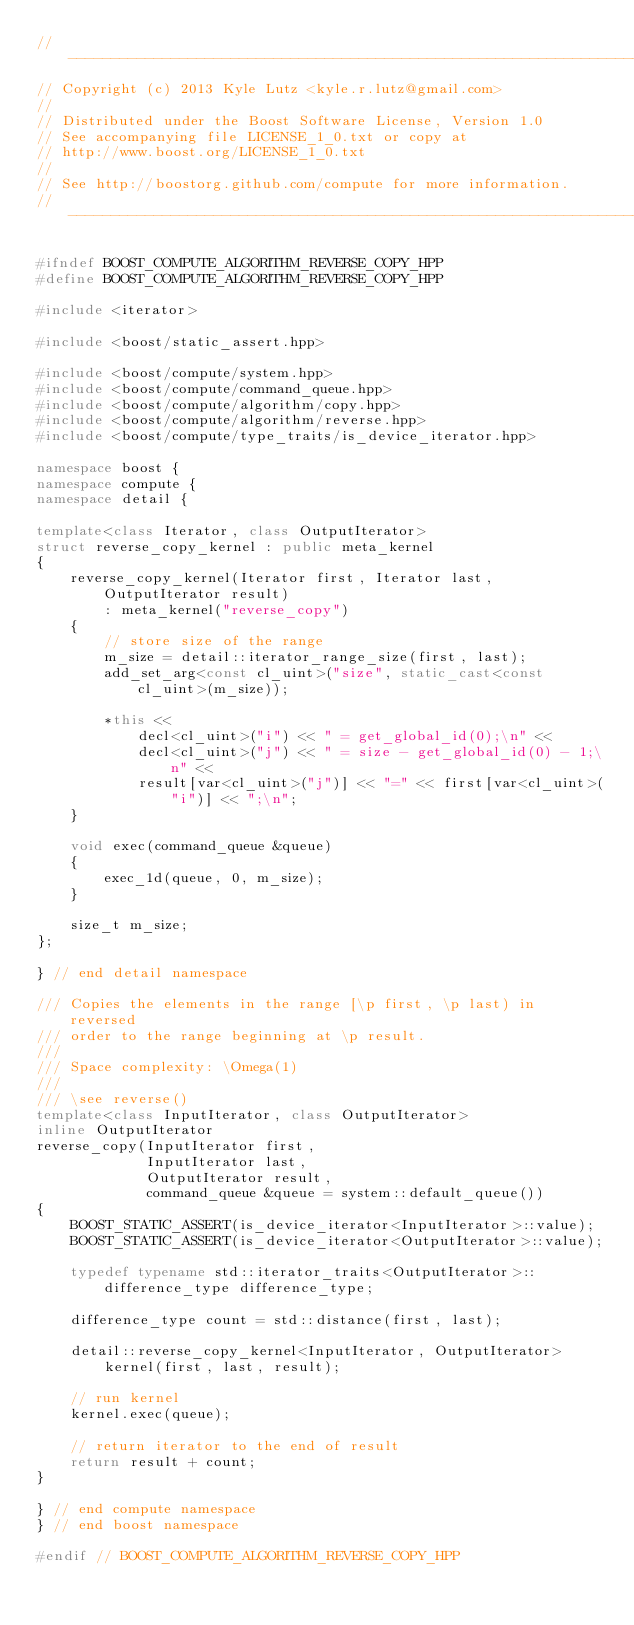Convert code to text. <code><loc_0><loc_0><loc_500><loc_500><_C++_>//---------------------------------------------------------------------------//
// Copyright (c) 2013 Kyle Lutz <kyle.r.lutz@gmail.com>
//
// Distributed under the Boost Software License, Version 1.0
// See accompanying file LICENSE_1_0.txt or copy at
// http://www.boost.org/LICENSE_1_0.txt
//
// See http://boostorg.github.com/compute for more information.
//---------------------------------------------------------------------------//

#ifndef BOOST_COMPUTE_ALGORITHM_REVERSE_COPY_HPP
#define BOOST_COMPUTE_ALGORITHM_REVERSE_COPY_HPP

#include <iterator>

#include <boost/static_assert.hpp>

#include <boost/compute/system.hpp>
#include <boost/compute/command_queue.hpp>
#include <boost/compute/algorithm/copy.hpp>
#include <boost/compute/algorithm/reverse.hpp>
#include <boost/compute/type_traits/is_device_iterator.hpp>

namespace boost {
namespace compute {
namespace detail {

template<class Iterator, class OutputIterator>
struct reverse_copy_kernel : public meta_kernel
{
    reverse_copy_kernel(Iterator first, Iterator last, OutputIterator result)
        : meta_kernel("reverse_copy")
    {
        // store size of the range
        m_size = detail::iterator_range_size(first, last);
        add_set_arg<const cl_uint>("size", static_cast<const cl_uint>(m_size));

        *this <<
            decl<cl_uint>("i") << " = get_global_id(0);\n" <<
            decl<cl_uint>("j") << " = size - get_global_id(0) - 1;\n" <<
            result[var<cl_uint>("j")] << "=" << first[var<cl_uint>("i")] << ";\n";
    }

    void exec(command_queue &queue)
    {
        exec_1d(queue, 0, m_size);
    }

    size_t m_size;
};

} // end detail namespace

/// Copies the elements in the range [\p first, \p last) in reversed
/// order to the range beginning at \p result.
///
/// Space complexity: \Omega(1)
///
/// \see reverse()
template<class InputIterator, class OutputIterator>
inline OutputIterator
reverse_copy(InputIterator first,
             InputIterator last,
             OutputIterator result,
             command_queue &queue = system::default_queue())
{
    BOOST_STATIC_ASSERT(is_device_iterator<InputIterator>::value);
    BOOST_STATIC_ASSERT(is_device_iterator<OutputIterator>::value);

    typedef typename std::iterator_traits<OutputIterator>::difference_type difference_type;

    difference_type count = std::distance(first, last);

    detail::reverse_copy_kernel<InputIterator, OutputIterator>
        kernel(first, last, result);

    // run kernel
    kernel.exec(queue);

    // return iterator to the end of result
    return result + count;
}

} // end compute namespace
} // end boost namespace

#endif // BOOST_COMPUTE_ALGORITHM_REVERSE_COPY_HPP
</code> 